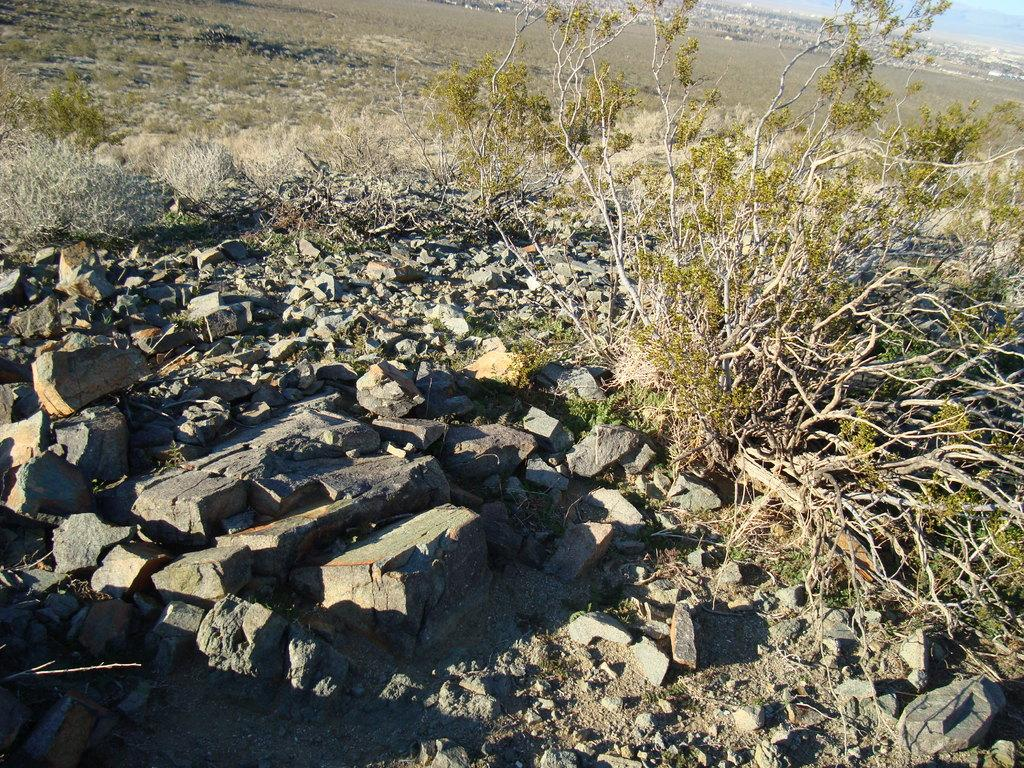What type of natural elements can be seen in the image? There are stones, trees, and plants visible in the image. What is the ground like in the image? The ground is visible in the image. Are there any man-made structures in the image? Yes, there are buildings in the image. What part of the natural environment is visible in the image? The sky is visible in the image. What color is the orange in the image? There is no orange present in the image. What time of day is depicted in the image? The time of day cannot be determined from the image, as there are no specific indicators of time. 